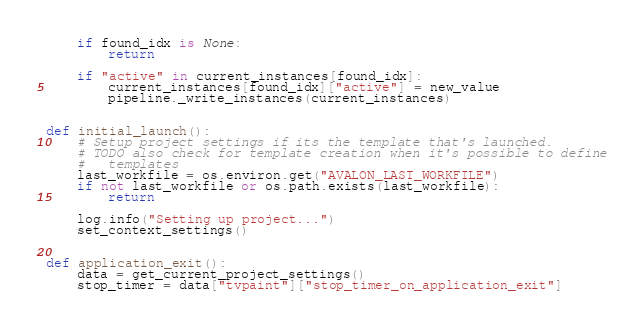Convert code to text. <code><loc_0><loc_0><loc_500><loc_500><_Python_>    if found_idx is None:
        return

    if "active" in current_instances[found_idx]:
        current_instances[found_idx]["active"] = new_value
        pipeline._write_instances(current_instances)


def initial_launch():
    # Setup project settings if its the template that's launched.
    # TODO also check for template creation when it's possible to define
    #   templates
    last_workfile = os.environ.get("AVALON_LAST_WORKFILE")
    if not last_workfile or os.path.exists(last_workfile):
        return

    log.info("Setting up project...")
    set_context_settings()


def application_exit():
    data = get_current_project_settings()
    stop_timer = data["tvpaint"]["stop_timer_on_application_exit"]
</code> 